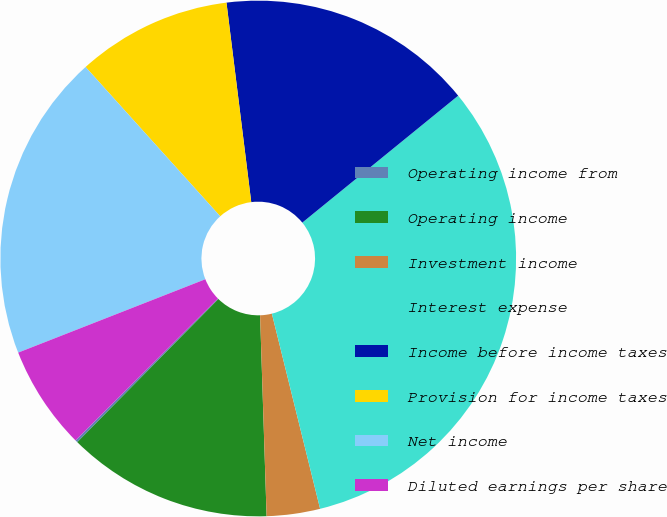Convert chart to OTSL. <chart><loc_0><loc_0><loc_500><loc_500><pie_chart><fcel>Operating income from<fcel>Operating income<fcel>Investment income<fcel>Interest expense<fcel>Income before income taxes<fcel>Provision for income taxes<fcel>Net income<fcel>Diluted earnings per share<nl><fcel>0.15%<fcel>12.9%<fcel>3.34%<fcel>32.02%<fcel>16.09%<fcel>9.71%<fcel>19.27%<fcel>6.52%<nl></chart> 